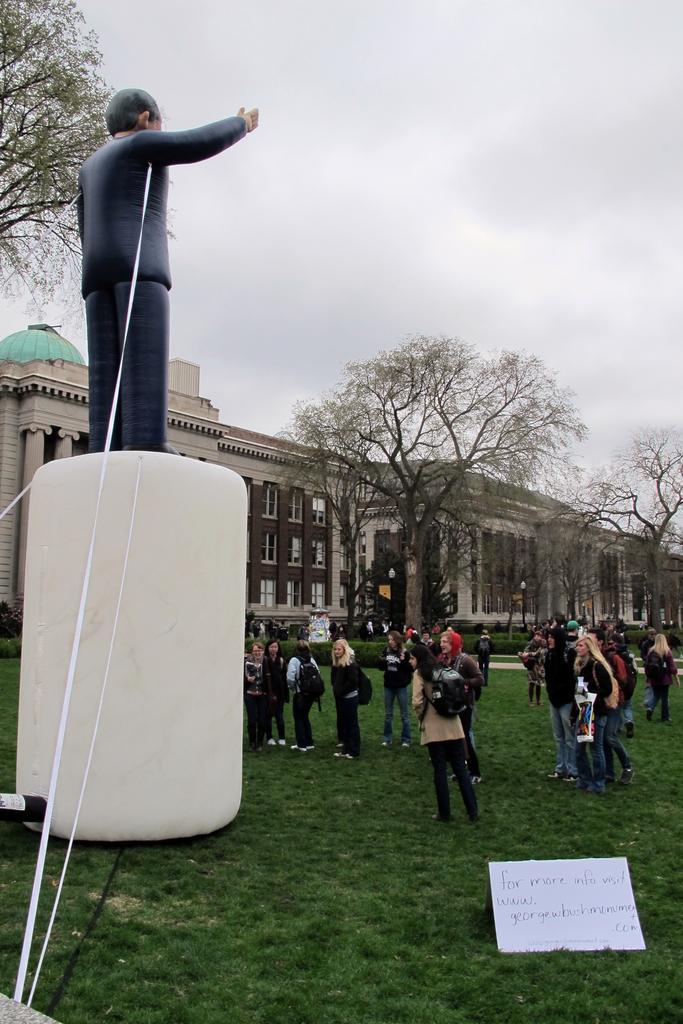Please provide a concise description of this image. In the center of the picture there are people, many of them are wearing bags. On the right there is a board. On the left there is a balloon toy. On the foreground there is glass. In the background there are trees and building. Sky is cloudy. 